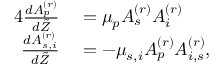Convert formula to latex. <formula><loc_0><loc_0><loc_500><loc_500>\begin{array} { r l } { { 4 } \frac { d A _ { p } ^ { ( r ) } } { d \tilde { Z } } } & = \mu _ { p } A _ { s } ^ { ( r ) } A _ { i } ^ { ( r ) } } \\ { \frac { d A _ { s , i } ^ { ( r ) } } { d \tilde { Z } } } & = - \mu _ { s , i } A _ { p } ^ { ( r ) } A _ { i , s } ^ { ( r ) } , } \end{array}</formula> 